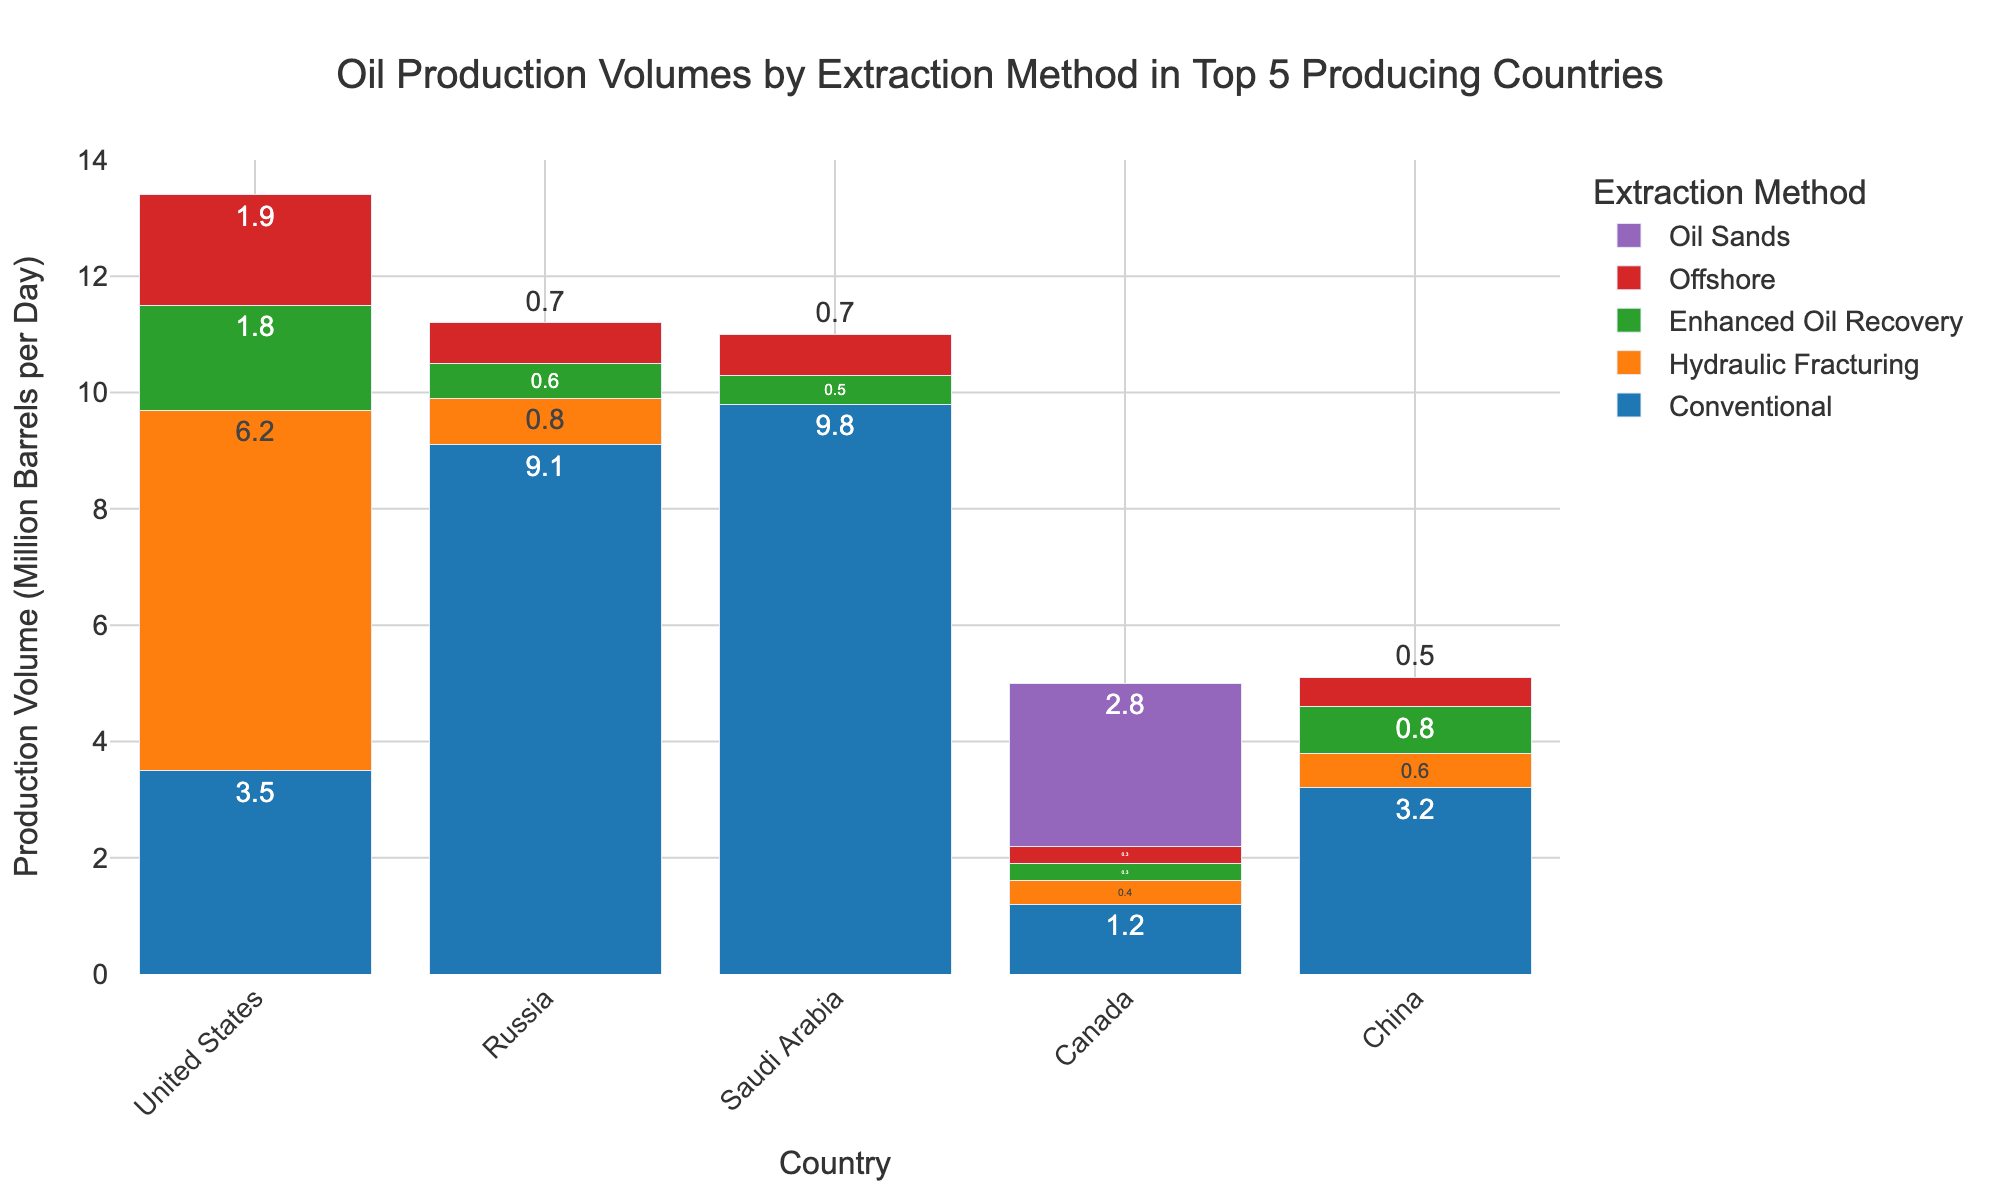How much oil is produced by Russia through Conventional methods and Offshore methods combined? First, identify the production volume for Conventional methods (9.1) and Offshore methods (0.7) in Russia. Then, add these two numbers together: 9.1 + 0.7 = 9.8 million barrels per day
Answer: 9.8 Which country produces the most oil using Hydraulic Fracturing? Look at the heights of the bars representing Hydraulic Fracturing for each country. The United States has the tallest bar at 6.2 million barrels per day.
Answer: United States How does the conventional oil production in the United States compare to that in Canada? Compare the bars for Conventional oil production between these two countries. The United States produces 3.5 million barrels per day and Canada produces 1.2 million barrels per day. 3.5 is greater than 1.2.
Answer: The United States produces more What is the total oil production volume for the United States across all extraction methods? Sum the production volumes for the United States: 3.5 (Conventional) + 6.2 (Hydraulic Fracturing) + 1.8 (Enhanced Oil Recovery) + 1.9 (Offshore) + 0 (Oil Sands) = 13.4 million barrels per day
Answer: 13.4 Which extraction method is used exclusively by four out of the five countries? By checking each extraction method, Oil Sands is used only by Canada and none of the other four countries.
Answer: Oil Sands Which country has the highest production in Offshore extraction methods? Compare the Offshore production bars for each country. The United States has 1.9 million barrels per day, which is the highest among all countries listed.
Answer: United States How much more oil does Saudi Arabia produce using Conventional methods compared to Enhanced Oil Recovery? Identify and subtract the volumes: Conventional (9.8) - Enhanced Oil Recovery (0.5) = 9.3 million barrels per day
Answer: 9.3 Arrange the countries in descending order based on their total oil production through Conventional methods. The production volumes for Conventional methods are: Saudi Arabia (9.8), Russia (9.1), China (3.2), United States (3.5), Canada (1.2). Therefore, the descending order is: Saudi Arabia, Russia, United States, China, Canada
Answer: Saudi Arabia, Russia, United States, China, Canada 